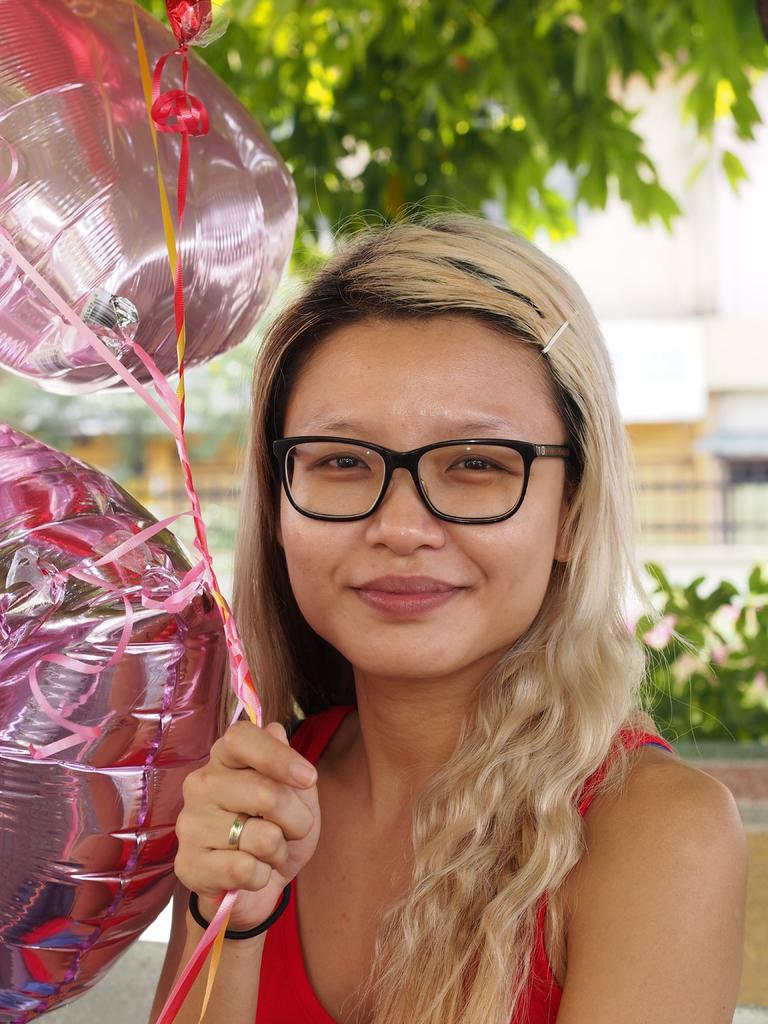Who is the main subject in the image? There is a girl in the image. What is the girl doing in the image? The girl is standing and smiling. What is the girl holding in the image? The girl is holding balloons. What can be seen in the background of the image? There are plants, trees, and buildings in the background of the image. What tax rate is applied to the balloons in the image? There is no mention of taxes in the image, and balloons are not subject to taxation. 